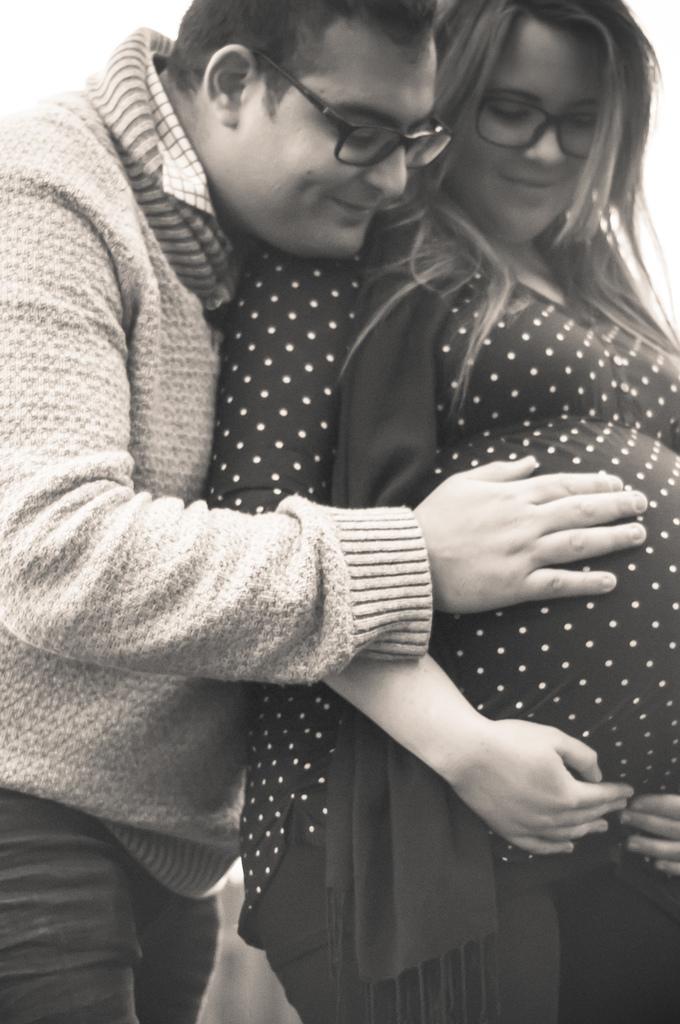Please provide a concise description of this image. In this image I can see two persons standing, the person at left wearing jacket and the image is in black and white. 